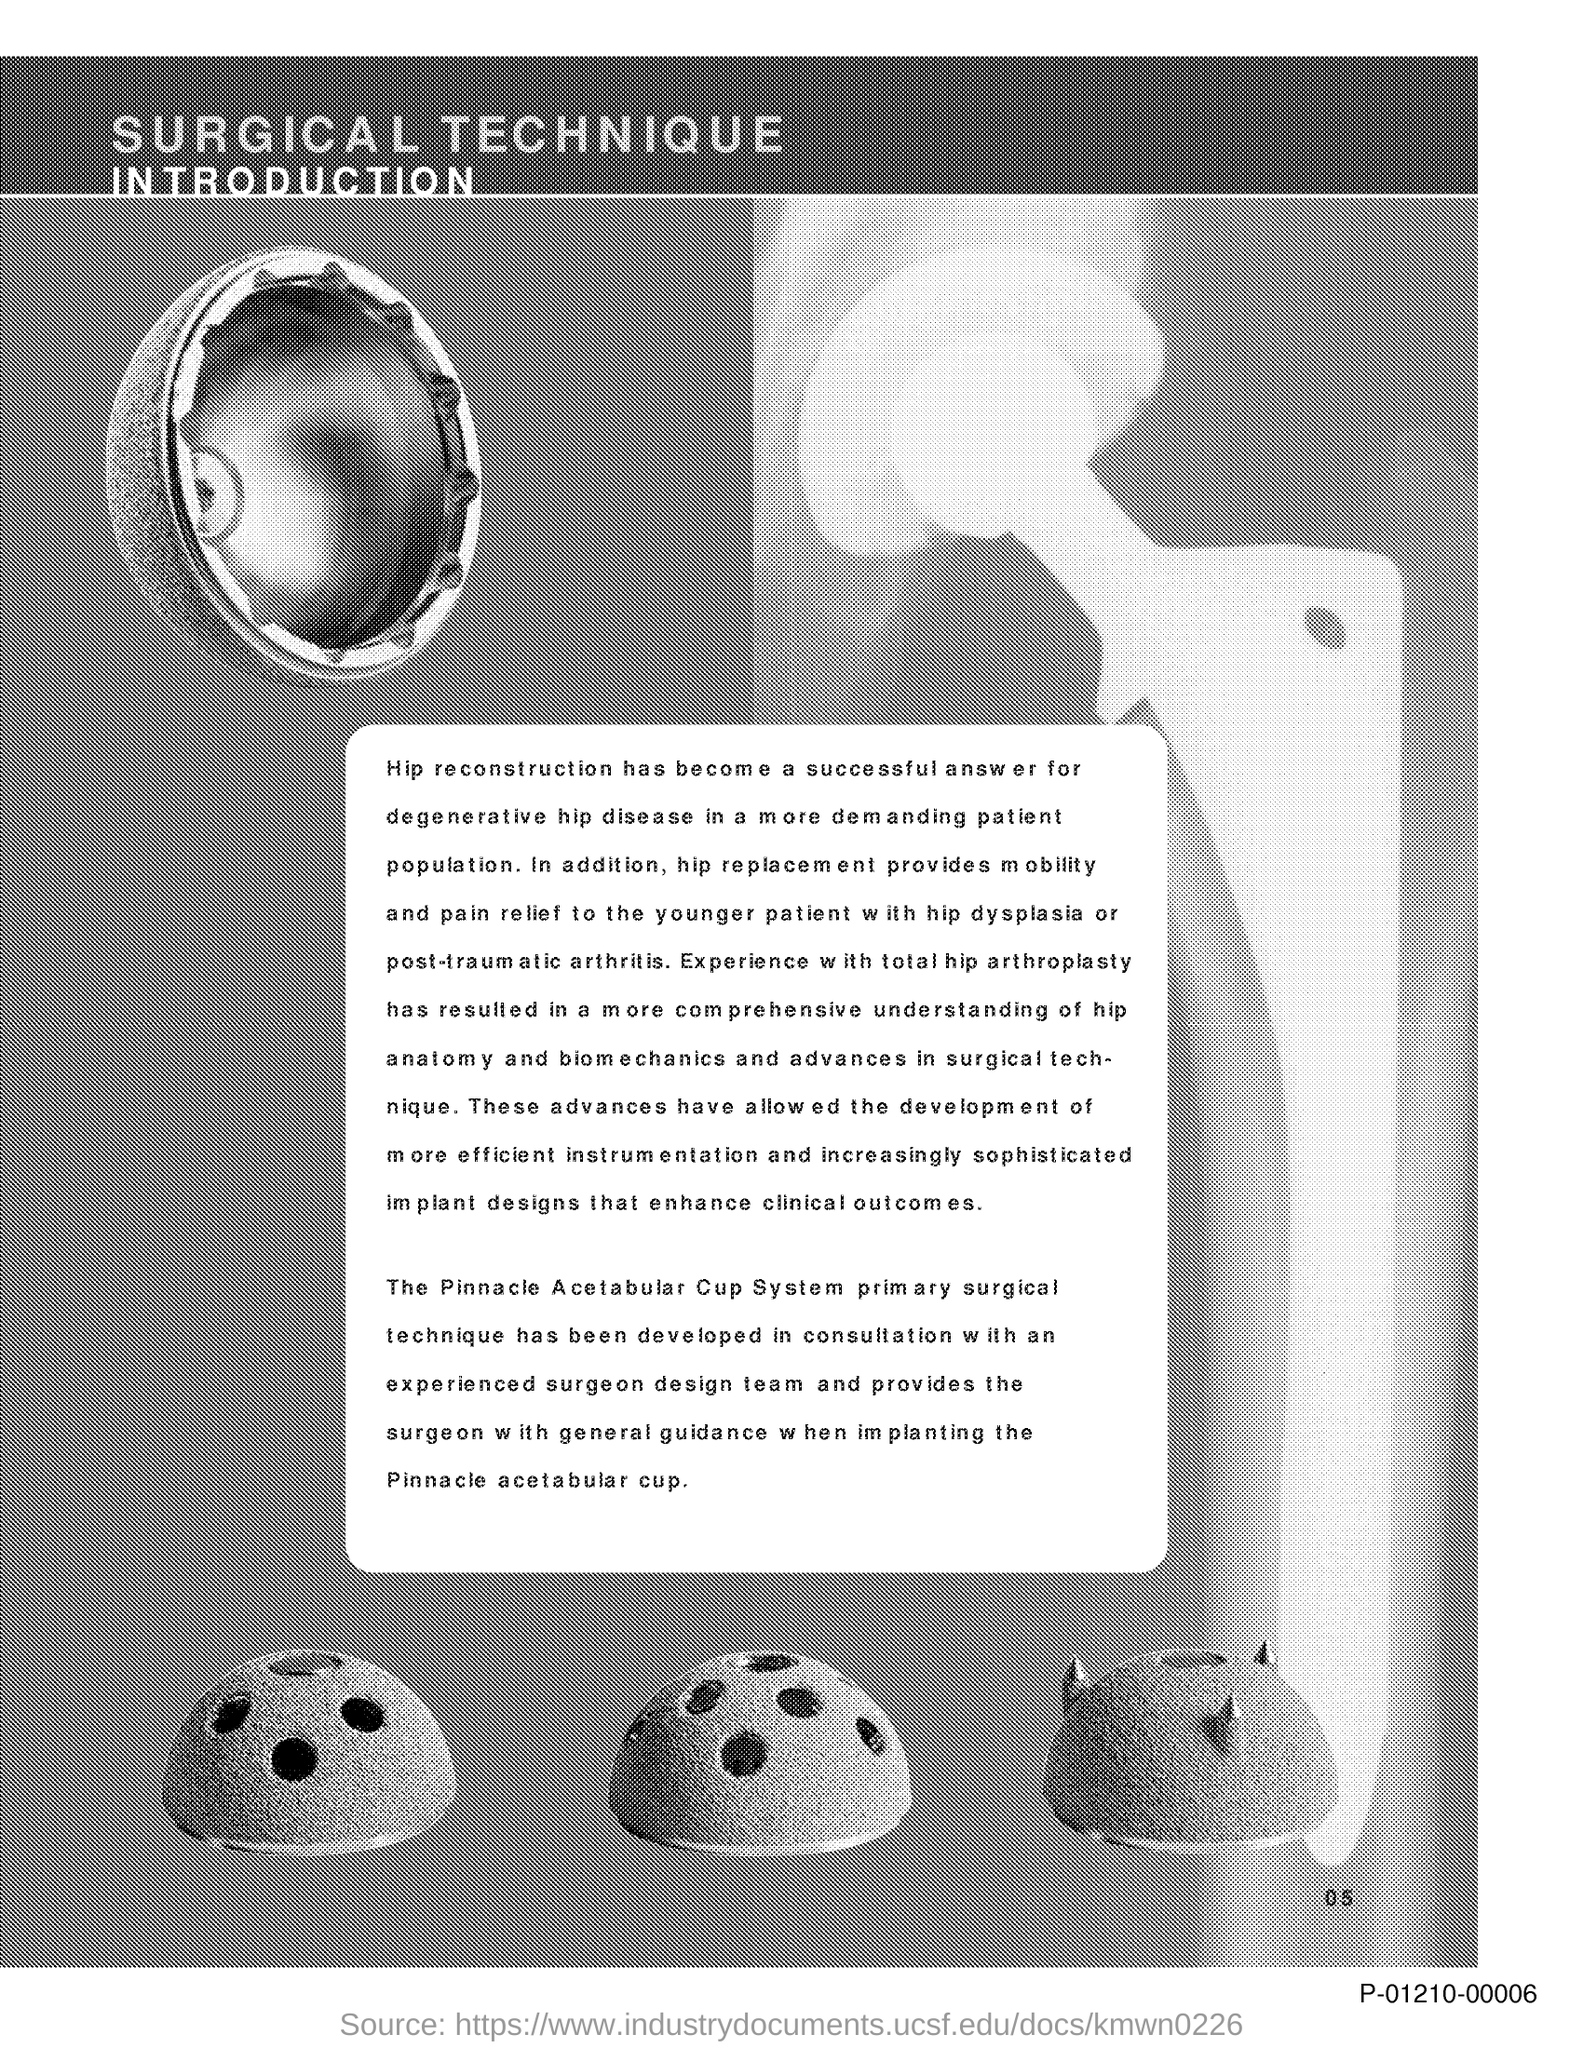What is the successful answer for degenerative hip disease?
Your answer should be compact. Hip reconstruction. 